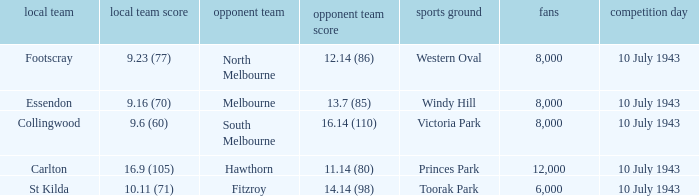When the Home team of carlton played, what was their score? 16.9 (105). 